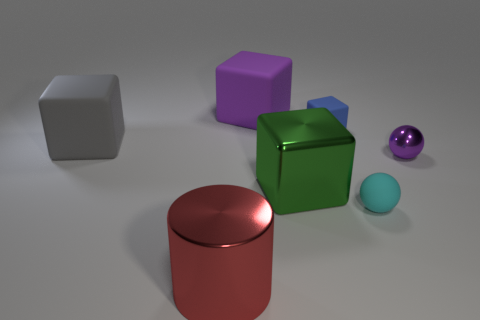How many big brown matte things are there?
Offer a terse response. 0. Is the material of the purple object that is in front of the big purple object the same as the gray object?
Make the answer very short. No. Are there any other things that have the same material as the gray cube?
Your response must be concise. Yes. What number of cubes are to the right of the matte thing left of the big matte block that is to the right of the large gray matte cube?
Keep it short and to the point. 3. How big is the green metal object?
Give a very brief answer. Large. Does the small shiny ball have the same color as the big metallic cylinder?
Provide a short and direct response. No. What size is the object that is right of the matte sphere?
Offer a very short reply. Small. There is a large shiny object that is to the right of the large purple matte cube; is its color the same as the large rubber cube that is to the right of the gray rubber cube?
Your response must be concise. No. What number of other things are there of the same shape as the green metallic thing?
Ensure brevity in your answer.  3. Are there the same number of red objects that are left of the gray rubber block and tiny rubber objects in front of the large red thing?
Offer a terse response. Yes. 